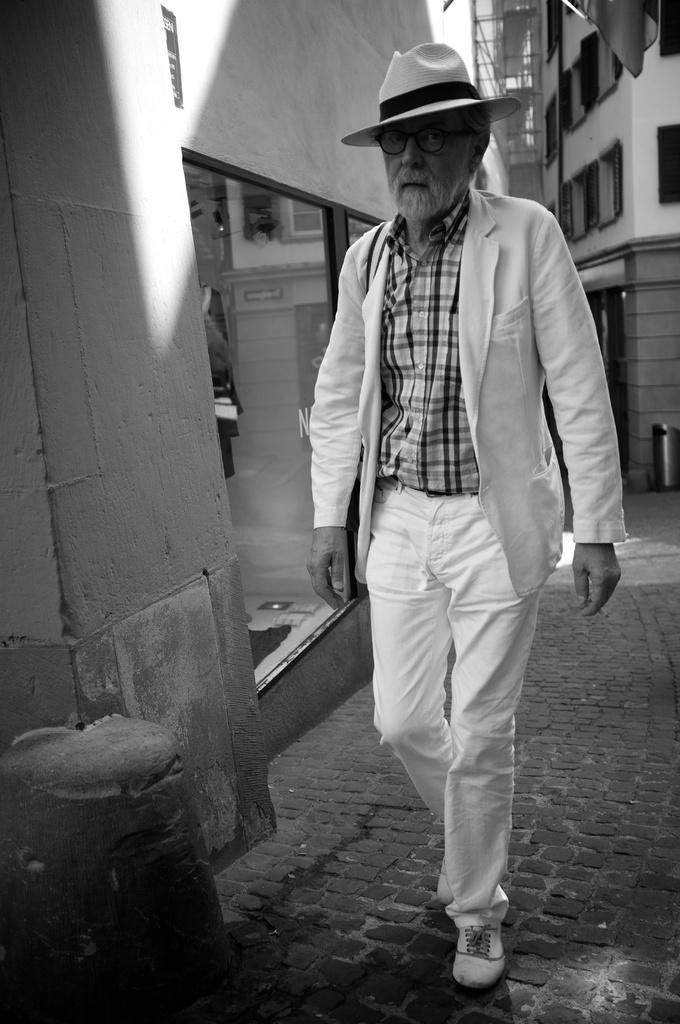What is the color scheme of the image? The image is in black and white. Who is the main subject in the image? There is an old man in the image. What is the old man wearing? The old man is wearing a white blazer, white trousers, a white hat, and a check shirt. What can be seen in the background of the image? There are buildings in the background of the image. What type of cracker is the old man holding in the image? There is no cracker present in the image. Is the old man reading a book in the image? There is no book visible in the image, so it cannot be determined if the old man is reading. --- Facts: 1. There is a car in the image. 2. The car is red. 3. The car has four wheels. 4. The car has a sunroof. 5. There are people in the car. 6. The car is parked on the street. Absurd Topics: parrot, sand, volcano Conversation: What is the main subject of the image? The main subject of the image is a car. What color is the car? The car is red. How many wheels does the car have? The car has four wheels. What feature does the car have on its roof? The car has a sunroof. Are there any passengers in the car? Yes, there are people in the car. Where is the car located in the image? The car is parked on the street. Reasoning: Let's think step by step in order to produce the conversation. We start by identifying the main subject in the image, which is the car. Then, we describe the car's color, number of wheels, and the presence of a sunroof. Next, we acknowledge the presence of people in the car and describe the car's location, which is parked on the street. Absurd Question/Answer: Can you see a parrot sitting on the car's sunroof in the image? No, there is no parrot present in the image. Is the car parked near a volcano in the image? No, there is no volcano present in the image. 